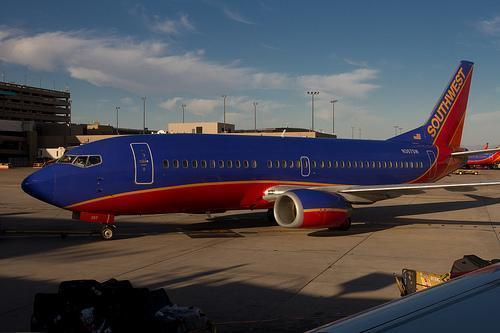How many planes are fully visible?
Give a very brief answer. 1. How many planes are in this picture?
Give a very brief answer. 2. 